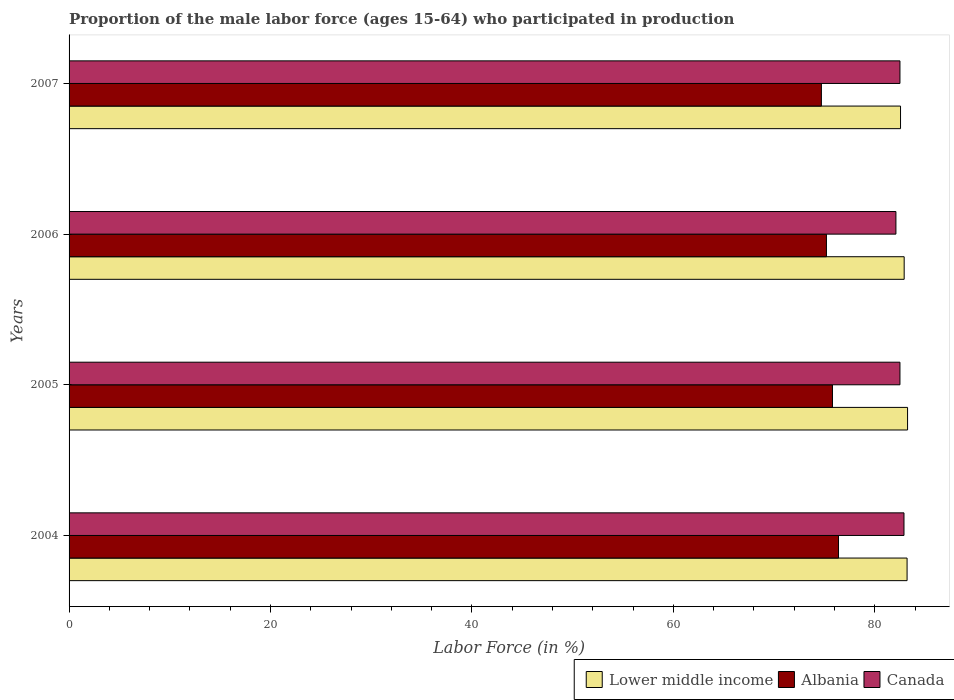Are the number of bars per tick equal to the number of legend labels?
Your answer should be very brief. Yes. What is the label of the 3rd group of bars from the top?
Make the answer very short. 2005. What is the proportion of the male labor force who participated in production in Canada in 2006?
Provide a succinct answer. 82.1. Across all years, what is the maximum proportion of the male labor force who participated in production in Lower middle income?
Keep it short and to the point. 83.26. Across all years, what is the minimum proportion of the male labor force who participated in production in Albania?
Offer a very short reply. 74.7. In which year was the proportion of the male labor force who participated in production in Albania minimum?
Make the answer very short. 2007. What is the total proportion of the male labor force who participated in production in Canada in the graph?
Your response must be concise. 330. What is the difference between the proportion of the male labor force who participated in production in Albania in 2004 and that in 2005?
Make the answer very short. 0.6. What is the difference between the proportion of the male labor force who participated in production in Lower middle income in 2004 and the proportion of the male labor force who participated in production in Albania in 2006?
Your response must be concise. 8.01. What is the average proportion of the male labor force who participated in production in Albania per year?
Ensure brevity in your answer.  75.52. In the year 2007, what is the difference between the proportion of the male labor force who participated in production in Albania and proportion of the male labor force who participated in production in Lower middle income?
Your answer should be compact. -7.86. In how many years, is the proportion of the male labor force who participated in production in Canada greater than 48 %?
Your answer should be compact. 4. What is the ratio of the proportion of the male labor force who participated in production in Canada in 2004 to that in 2006?
Offer a very short reply. 1.01. What is the difference between the highest and the second highest proportion of the male labor force who participated in production in Albania?
Keep it short and to the point. 0.6. What is the difference between the highest and the lowest proportion of the male labor force who participated in production in Lower middle income?
Your response must be concise. 0.7. What does the 1st bar from the top in 2007 represents?
Your answer should be compact. Canada. What does the 1st bar from the bottom in 2006 represents?
Your response must be concise. Lower middle income. How many bars are there?
Keep it short and to the point. 12. How many years are there in the graph?
Make the answer very short. 4. What is the difference between two consecutive major ticks on the X-axis?
Make the answer very short. 20. Does the graph contain grids?
Keep it short and to the point. No. Where does the legend appear in the graph?
Give a very brief answer. Bottom right. How many legend labels are there?
Offer a very short reply. 3. How are the legend labels stacked?
Provide a short and direct response. Horizontal. What is the title of the graph?
Make the answer very short. Proportion of the male labor force (ages 15-64) who participated in production. Does "Korea (Republic)" appear as one of the legend labels in the graph?
Provide a short and direct response. No. What is the Labor Force (in %) of Lower middle income in 2004?
Give a very brief answer. 83.21. What is the Labor Force (in %) in Albania in 2004?
Make the answer very short. 76.4. What is the Labor Force (in %) in Canada in 2004?
Provide a succinct answer. 82.9. What is the Labor Force (in %) of Lower middle income in 2005?
Make the answer very short. 83.26. What is the Labor Force (in %) of Albania in 2005?
Provide a succinct answer. 75.8. What is the Labor Force (in %) of Canada in 2005?
Ensure brevity in your answer.  82.5. What is the Labor Force (in %) in Lower middle income in 2006?
Offer a very short reply. 82.92. What is the Labor Force (in %) in Albania in 2006?
Keep it short and to the point. 75.2. What is the Labor Force (in %) of Canada in 2006?
Offer a terse response. 82.1. What is the Labor Force (in %) of Lower middle income in 2007?
Your answer should be compact. 82.56. What is the Labor Force (in %) of Albania in 2007?
Offer a terse response. 74.7. What is the Labor Force (in %) of Canada in 2007?
Provide a succinct answer. 82.5. Across all years, what is the maximum Labor Force (in %) of Lower middle income?
Give a very brief answer. 83.26. Across all years, what is the maximum Labor Force (in %) of Albania?
Keep it short and to the point. 76.4. Across all years, what is the maximum Labor Force (in %) in Canada?
Your answer should be compact. 82.9. Across all years, what is the minimum Labor Force (in %) of Lower middle income?
Your answer should be compact. 82.56. Across all years, what is the minimum Labor Force (in %) of Albania?
Make the answer very short. 74.7. Across all years, what is the minimum Labor Force (in %) of Canada?
Provide a succinct answer. 82.1. What is the total Labor Force (in %) of Lower middle income in the graph?
Make the answer very short. 331.94. What is the total Labor Force (in %) in Albania in the graph?
Give a very brief answer. 302.1. What is the total Labor Force (in %) in Canada in the graph?
Give a very brief answer. 330. What is the difference between the Labor Force (in %) of Lower middle income in 2004 and that in 2005?
Your answer should be very brief. -0.05. What is the difference between the Labor Force (in %) of Canada in 2004 and that in 2005?
Provide a short and direct response. 0.4. What is the difference between the Labor Force (in %) of Lower middle income in 2004 and that in 2006?
Your answer should be compact. 0.29. What is the difference between the Labor Force (in %) of Lower middle income in 2004 and that in 2007?
Ensure brevity in your answer.  0.65. What is the difference between the Labor Force (in %) of Albania in 2004 and that in 2007?
Your answer should be compact. 1.7. What is the difference between the Labor Force (in %) in Canada in 2004 and that in 2007?
Give a very brief answer. 0.4. What is the difference between the Labor Force (in %) in Lower middle income in 2005 and that in 2006?
Provide a succinct answer. 0.34. What is the difference between the Labor Force (in %) in Canada in 2005 and that in 2006?
Your answer should be very brief. 0.4. What is the difference between the Labor Force (in %) of Lower middle income in 2005 and that in 2007?
Keep it short and to the point. 0.7. What is the difference between the Labor Force (in %) of Albania in 2005 and that in 2007?
Offer a very short reply. 1.1. What is the difference between the Labor Force (in %) of Lower middle income in 2006 and that in 2007?
Your answer should be very brief. 0.36. What is the difference between the Labor Force (in %) in Albania in 2006 and that in 2007?
Provide a succinct answer. 0.5. What is the difference between the Labor Force (in %) of Canada in 2006 and that in 2007?
Ensure brevity in your answer.  -0.4. What is the difference between the Labor Force (in %) of Lower middle income in 2004 and the Labor Force (in %) of Albania in 2005?
Your answer should be very brief. 7.41. What is the difference between the Labor Force (in %) in Lower middle income in 2004 and the Labor Force (in %) in Canada in 2005?
Give a very brief answer. 0.71. What is the difference between the Labor Force (in %) in Albania in 2004 and the Labor Force (in %) in Canada in 2005?
Offer a terse response. -6.1. What is the difference between the Labor Force (in %) in Lower middle income in 2004 and the Labor Force (in %) in Albania in 2006?
Give a very brief answer. 8.01. What is the difference between the Labor Force (in %) in Lower middle income in 2004 and the Labor Force (in %) in Canada in 2006?
Offer a very short reply. 1.11. What is the difference between the Labor Force (in %) in Lower middle income in 2004 and the Labor Force (in %) in Albania in 2007?
Keep it short and to the point. 8.51. What is the difference between the Labor Force (in %) of Lower middle income in 2004 and the Labor Force (in %) of Canada in 2007?
Your response must be concise. 0.71. What is the difference between the Labor Force (in %) in Albania in 2004 and the Labor Force (in %) in Canada in 2007?
Keep it short and to the point. -6.1. What is the difference between the Labor Force (in %) in Lower middle income in 2005 and the Labor Force (in %) in Albania in 2006?
Make the answer very short. 8.06. What is the difference between the Labor Force (in %) of Lower middle income in 2005 and the Labor Force (in %) of Canada in 2006?
Make the answer very short. 1.16. What is the difference between the Labor Force (in %) of Albania in 2005 and the Labor Force (in %) of Canada in 2006?
Provide a short and direct response. -6.3. What is the difference between the Labor Force (in %) in Lower middle income in 2005 and the Labor Force (in %) in Albania in 2007?
Your response must be concise. 8.56. What is the difference between the Labor Force (in %) in Lower middle income in 2005 and the Labor Force (in %) in Canada in 2007?
Your response must be concise. 0.76. What is the difference between the Labor Force (in %) of Lower middle income in 2006 and the Labor Force (in %) of Albania in 2007?
Your answer should be compact. 8.22. What is the difference between the Labor Force (in %) in Lower middle income in 2006 and the Labor Force (in %) in Canada in 2007?
Your answer should be very brief. 0.42. What is the difference between the Labor Force (in %) in Albania in 2006 and the Labor Force (in %) in Canada in 2007?
Make the answer very short. -7.3. What is the average Labor Force (in %) in Lower middle income per year?
Make the answer very short. 82.99. What is the average Labor Force (in %) of Albania per year?
Give a very brief answer. 75.53. What is the average Labor Force (in %) in Canada per year?
Offer a very short reply. 82.5. In the year 2004, what is the difference between the Labor Force (in %) in Lower middle income and Labor Force (in %) in Albania?
Offer a very short reply. 6.81. In the year 2004, what is the difference between the Labor Force (in %) in Lower middle income and Labor Force (in %) in Canada?
Provide a succinct answer. 0.31. In the year 2004, what is the difference between the Labor Force (in %) in Albania and Labor Force (in %) in Canada?
Offer a very short reply. -6.5. In the year 2005, what is the difference between the Labor Force (in %) of Lower middle income and Labor Force (in %) of Albania?
Give a very brief answer. 7.46. In the year 2005, what is the difference between the Labor Force (in %) of Lower middle income and Labor Force (in %) of Canada?
Ensure brevity in your answer.  0.76. In the year 2005, what is the difference between the Labor Force (in %) of Albania and Labor Force (in %) of Canada?
Your answer should be very brief. -6.7. In the year 2006, what is the difference between the Labor Force (in %) in Lower middle income and Labor Force (in %) in Albania?
Offer a very short reply. 7.72. In the year 2006, what is the difference between the Labor Force (in %) in Lower middle income and Labor Force (in %) in Canada?
Provide a succinct answer. 0.82. In the year 2007, what is the difference between the Labor Force (in %) in Lower middle income and Labor Force (in %) in Albania?
Your response must be concise. 7.86. In the year 2007, what is the difference between the Labor Force (in %) of Lower middle income and Labor Force (in %) of Canada?
Ensure brevity in your answer.  0.06. What is the ratio of the Labor Force (in %) of Lower middle income in 2004 to that in 2005?
Make the answer very short. 1. What is the ratio of the Labor Force (in %) of Albania in 2004 to that in 2005?
Your answer should be compact. 1.01. What is the ratio of the Labor Force (in %) in Lower middle income in 2004 to that in 2006?
Offer a terse response. 1. What is the ratio of the Labor Force (in %) of Albania in 2004 to that in 2006?
Your response must be concise. 1.02. What is the ratio of the Labor Force (in %) in Canada in 2004 to that in 2006?
Your answer should be compact. 1.01. What is the ratio of the Labor Force (in %) of Lower middle income in 2004 to that in 2007?
Keep it short and to the point. 1.01. What is the ratio of the Labor Force (in %) of Albania in 2004 to that in 2007?
Offer a very short reply. 1.02. What is the ratio of the Labor Force (in %) of Canada in 2004 to that in 2007?
Your response must be concise. 1. What is the ratio of the Labor Force (in %) in Lower middle income in 2005 to that in 2006?
Your answer should be very brief. 1. What is the ratio of the Labor Force (in %) in Albania in 2005 to that in 2006?
Keep it short and to the point. 1.01. What is the ratio of the Labor Force (in %) of Lower middle income in 2005 to that in 2007?
Keep it short and to the point. 1.01. What is the ratio of the Labor Force (in %) of Albania in 2005 to that in 2007?
Your response must be concise. 1.01. What is the ratio of the Labor Force (in %) of Canada in 2005 to that in 2007?
Make the answer very short. 1. What is the ratio of the Labor Force (in %) of Lower middle income in 2006 to that in 2007?
Give a very brief answer. 1. What is the ratio of the Labor Force (in %) of Canada in 2006 to that in 2007?
Your answer should be very brief. 1. What is the difference between the highest and the second highest Labor Force (in %) of Lower middle income?
Make the answer very short. 0.05. What is the difference between the highest and the second highest Labor Force (in %) in Canada?
Your response must be concise. 0.4. What is the difference between the highest and the lowest Labor Force (in %) of Lower middle income?
Your response must be concise. 0.7. What is the difference between the highest and the lowest Labor Force (in %) in Albania?
Your answer should be very brief. 1.7. 